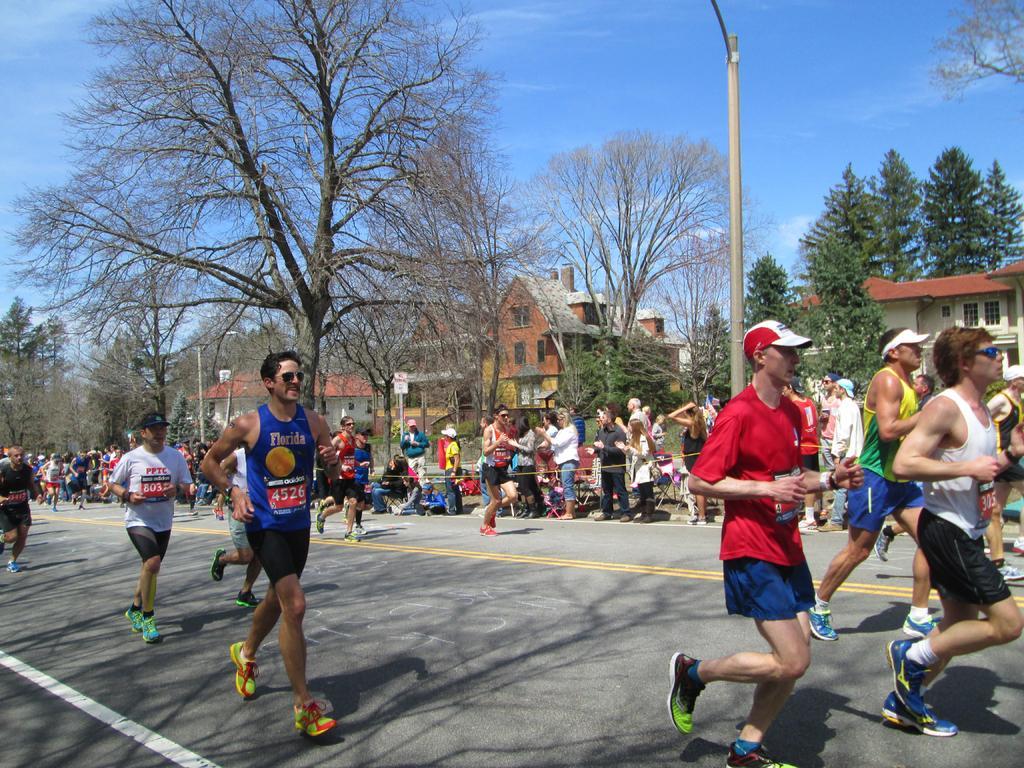How would you summarize this image in a sentence or two? In this image, we can see a group of people. Here we can see few people are running on the road. Background we can see buildings, houses, trees, plants, poles, boards and sky. 